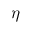<formula> <loc_0><loc_0><loc_500><loc_500>\eta</formula> 